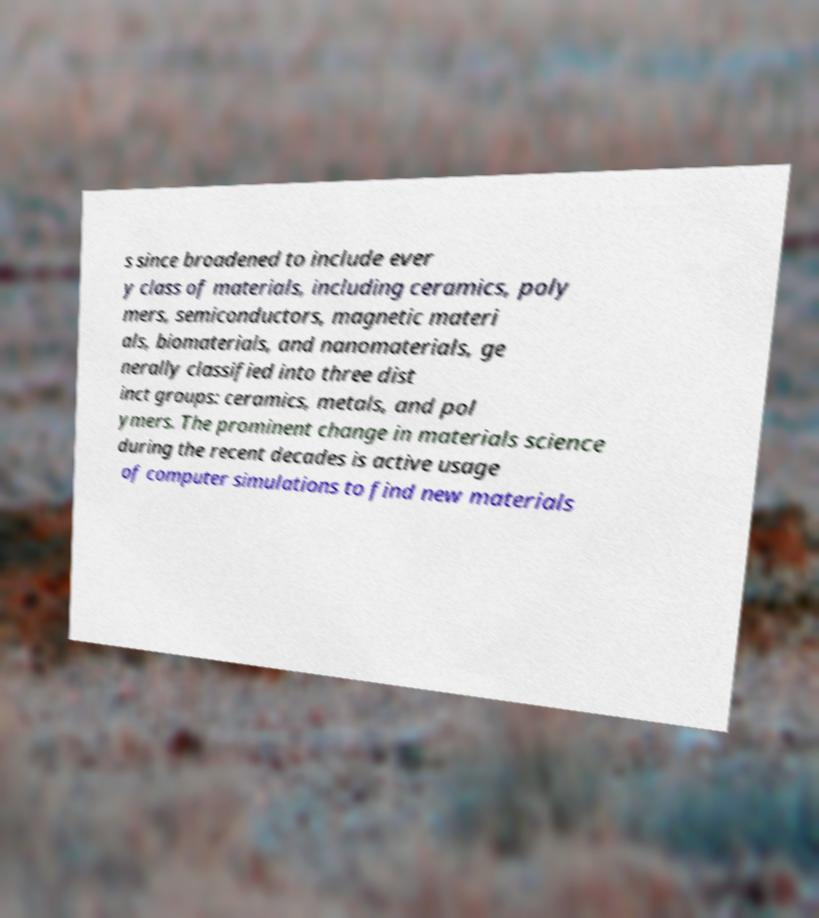Can you accurately transcribe the text from the provided image for me? s since broadened to include ever y class of materials, including ceramics, poly mers, semiconductors, magnetic materi als, biomaterials, and nanomaterials, ge nerally classified into three dist inct groups: ceramics, metals, and pol ymers. The prominent change in materials science during the recent decades is active usage of computer simulations to find new materials 